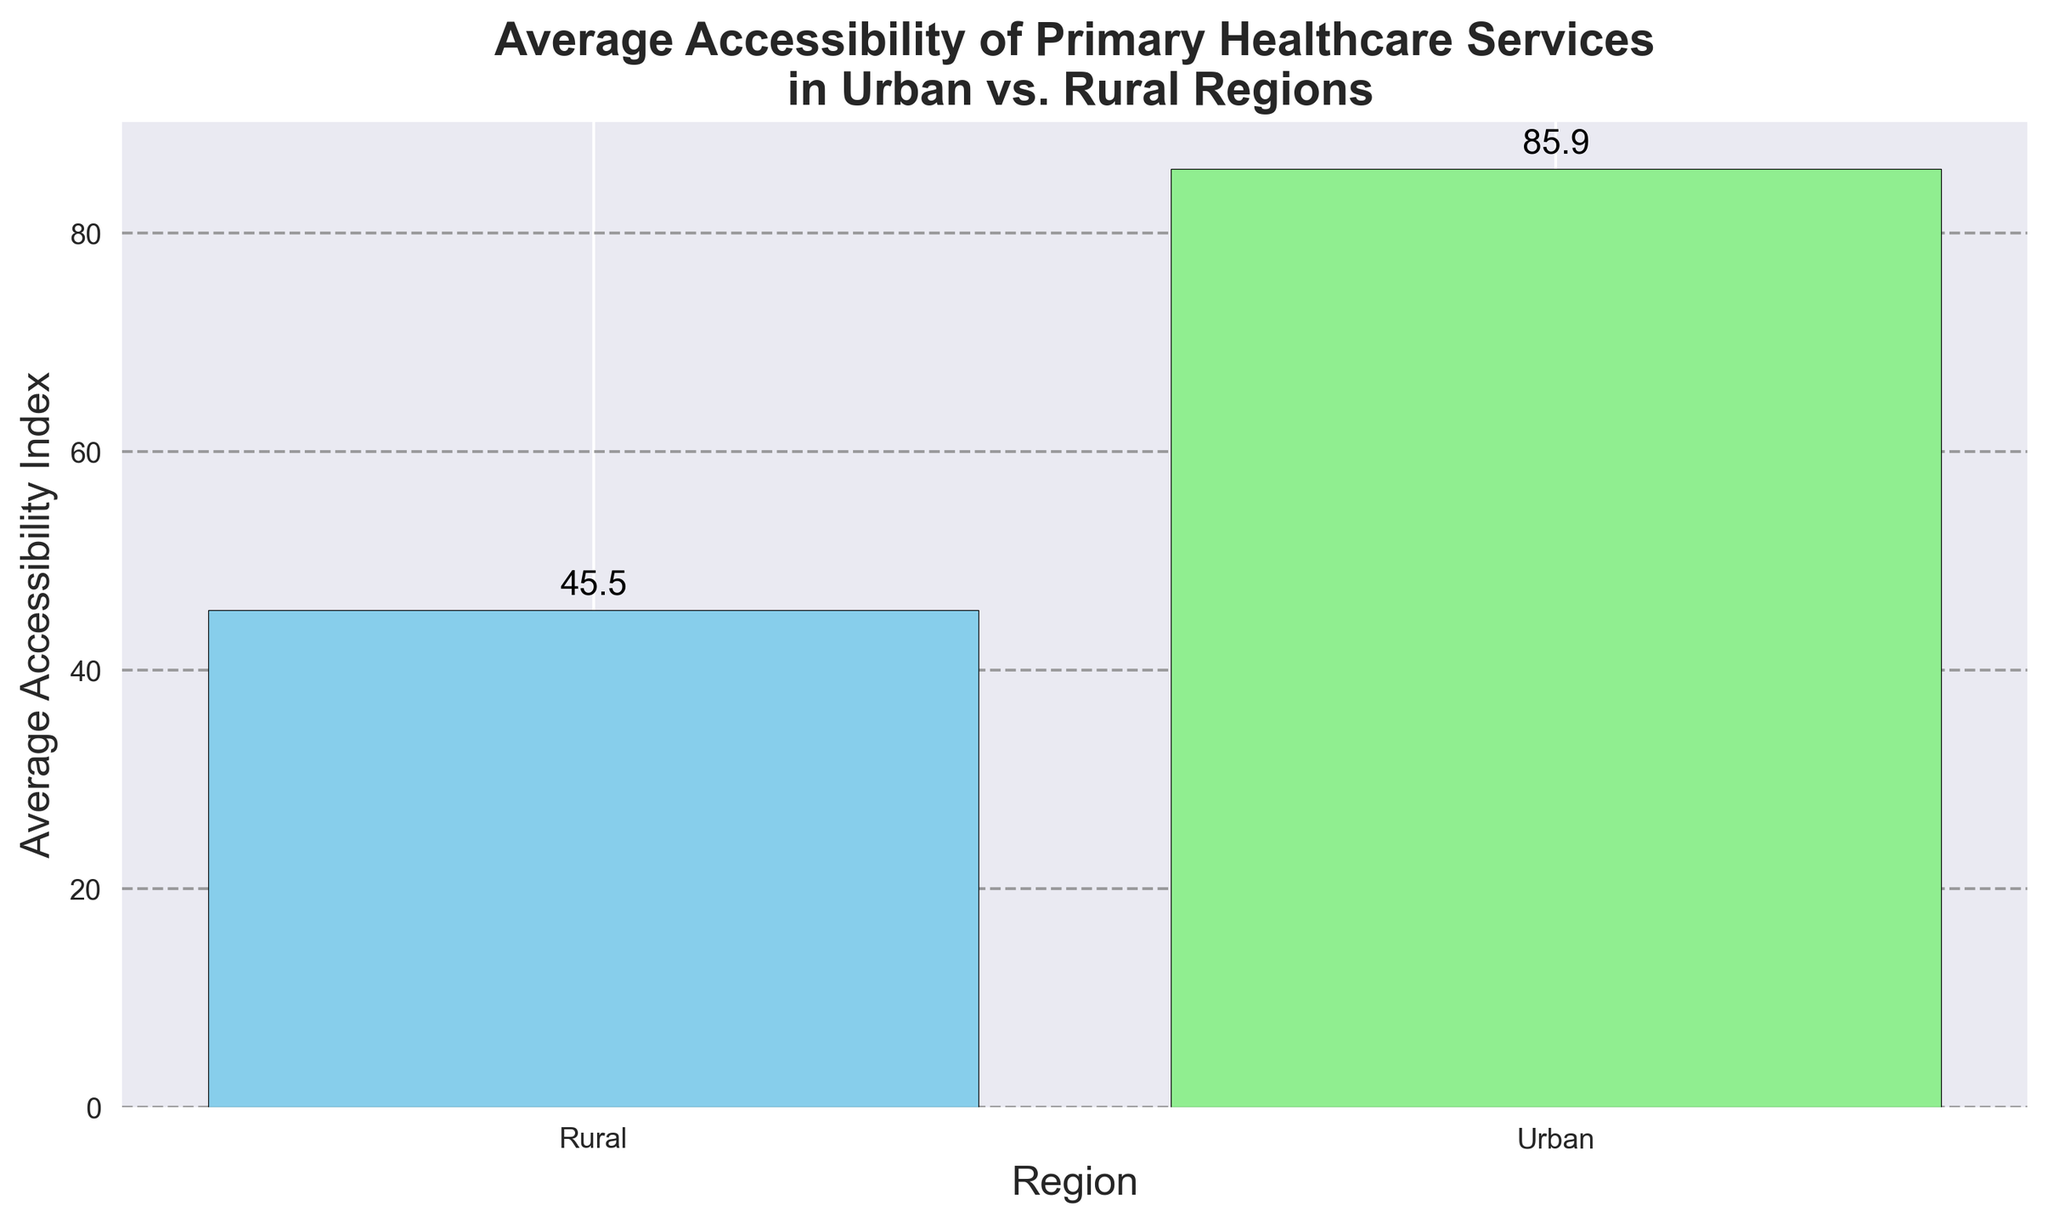What's the average Accessibility Index in Urban regions? The figure shows the average Accessibility Index for urban regions; visually refer to the bar height for urban data points to obtain the value, which is around 85.9
Answer: 85.9 What's the average Accessibility Index in Rural regions? The figure displays the average Accessibility Index value for rural regions; check the height of the bar representing rural regions, which is approximately 44.5
Answer: 44.5 How much higher is the average Accessibility Index in Urban regions compared to Rural regions? To find the difference, subtract the average Accessibility Index of Rural regions (44.5) from that of Urban regions (85.9): 85.9 - 44.5 = 41.4
Answer: 41.4 Compare the average Accessibility Index between Urban and Rural regions. Which one has a higher value and by how much? Urban regions have a higher average Accessibility Index compared to Rural regions. The difference between the two is calculated as 85.9 - 44.5 = 41.4
Answer: Urban by 41.4 What color represents the bar for Urban regions? Examine the color of the bar for Urban regions. It is represented by the color skyblue in the figure
Answer: skyblue What color is used for the bar representing Rural regions? Look at the bar depicting Rural regions; it is illustrated in lightgreen
Answer: lightgreen Is the Accessibility Index more consistent in Urban or Rural regions based on the average values? Urban regions have a higher and more consistent average Accessibility Index as indicated by the bar's height and the lesser variation among the data points
Answer: Urban According to the plot, did any region have an average Accessibility Index below 50? The Rural region has an average Accessibility Index below 50, as indicated by the height of the respective bar
Answer: Rural How have the various regions been annotated for their respective average values? Both bars in the plot for Urban and Rural regions have annotations displaying their average values; Urban at 85.9 and Rural at 44.5
Answer: Annotated with mean values What is the range of the y-axis gridlines used in the plot? The gridlines on the y-axis span from 0 to slightly above 90, marked to help visualize the bar heights better
Answer: 0 to slightly above 90 